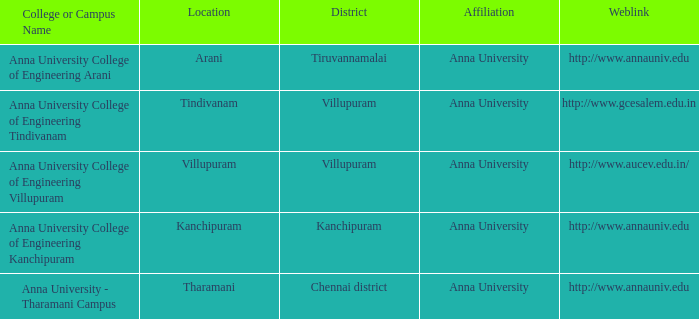What Weblink has a College or Campus Name of anna university college of engineering tindivanam? Http://www.gcesalem.edu.in. 